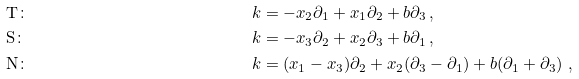<formula> <loc_0><loc_0><loc_500><loc_500>& \text {T} \colon & k & = - x _ { 2 } \partial _ { 1 } + x _ { 1 } \partial _ { 2 } + b \partial _ { 3 } \, , \\ & \text {S} \colon & k & = - x _ { 3 } \partial _ { 2 } + x _ { 2 } \partial _ { 3 } + b \partial _ { 1 } \, , \\ & \text {N} \colon & k & = ( x _ { 1 } - x _ { 3 } ) \partial _ { 2 } + x _ { 2 } ( \partial _ { 3 } - \partial _ { 1 } ) + b ( \partial _ { 1 } + \partial _ { 3 } ) \ ,</formula> 